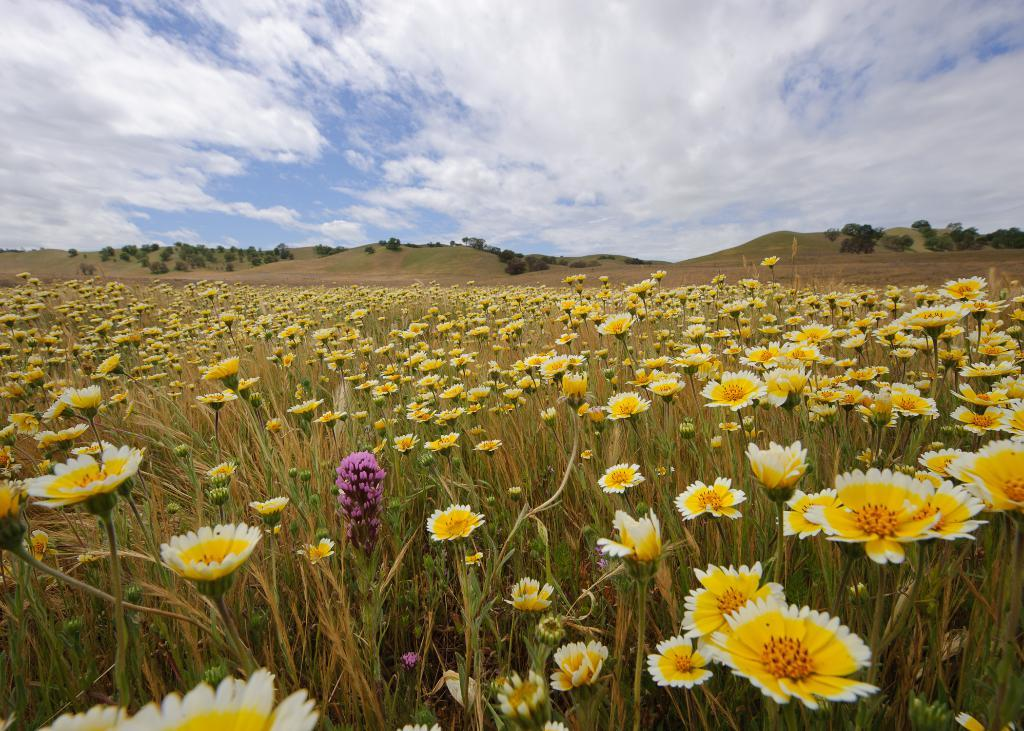What type of living organisms can be seen in the image? Plants and flowers are visible in the image. What can be seen in the sky in the image? The sky is visible in the image, and there are clouds present. What is in the background of the image? There are trees in the background of the image. What type of medical advice can be heard from the doctor in the image? There is no doctor present in the image, so no medical advice can be heard. 